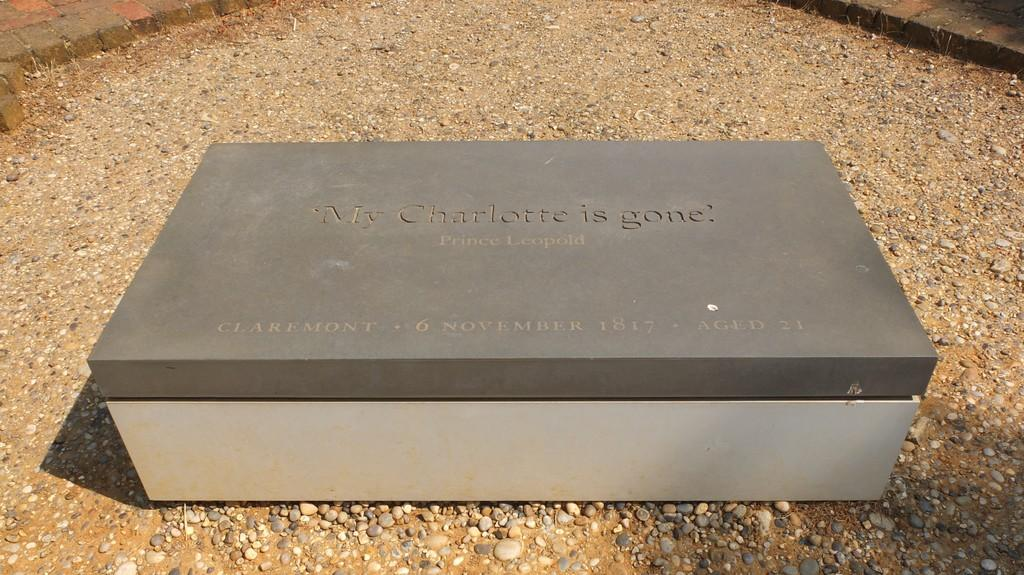Provide a one-sentence caption for the provided image. Some sort of gravestone reading "My Charlotte is gone" on the top of it. 